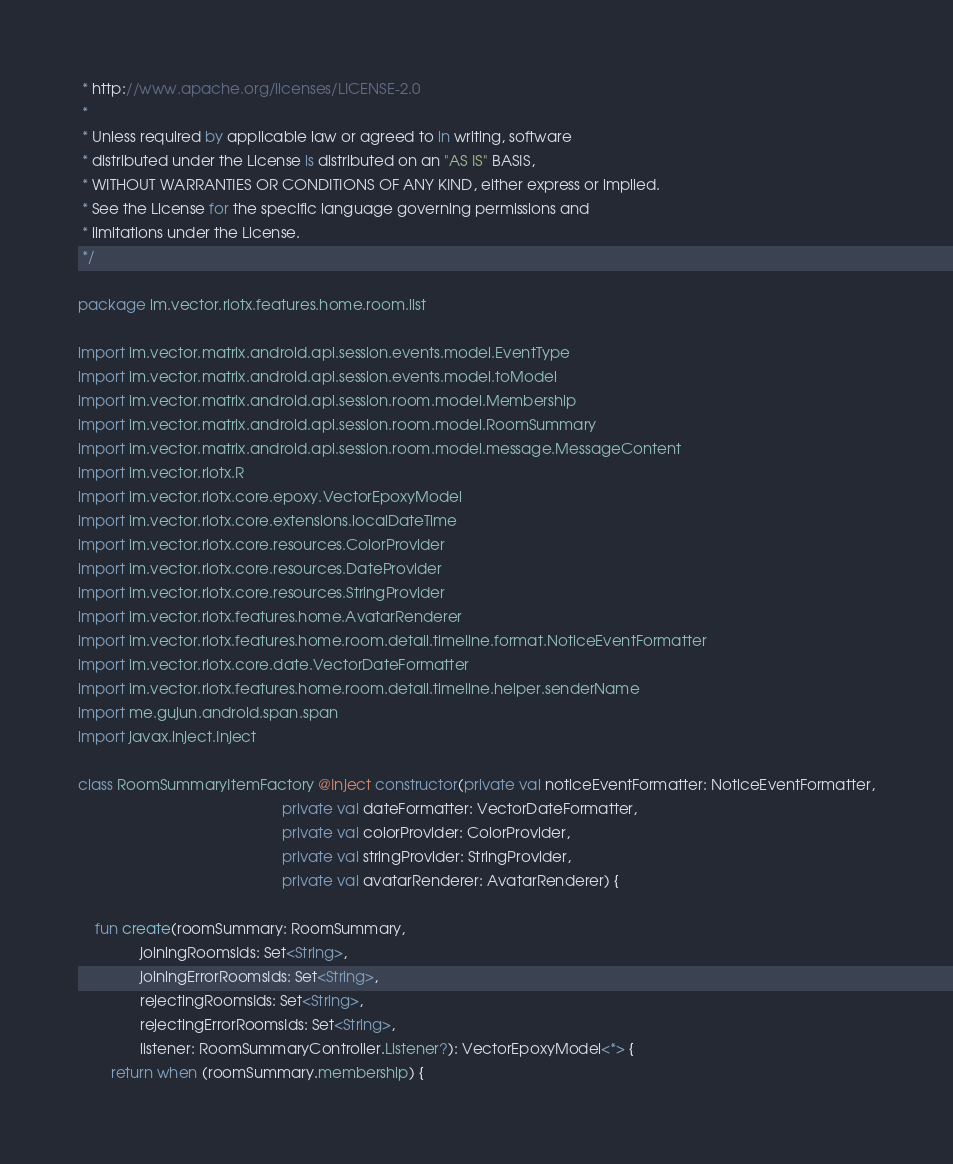Convert code to text. <code><loc_0><loc_0><loc_500><loc_500><_Kotlin_> * http://www.apache.org/licenses/LICENSE-2.0
 *
 * Unless required by applicable law or agreed to in writing, software
 * distributed under the License is distributed on an "AS IS" BASIS,
 * WITHOUT WARRANTIES OR CONDITIONS OF ANY KIND, either express or implied.
 * See the License for the specific language governing permissions and
 * limitations under the License.
 */

package im.vector.riotx.features.home.room.list

import im.vector.matrix.android.api.session.events.model.EventType
import im.vector.matrix.android.api.session.events.model.toModel
import im.vector.matrix.android.api.session.room.model.Membership
import im.vector.matrix.android.api.session.room.model.RoomSummary
import im.vector.matrix.android.api.session.room.model.message.MessageContent
import im.vector.riotx.R
import im.vector.riotx.core.epoxy.VectorEpoxyModel
import im.vector.riotx.core.extensions.localDateTime
import im.vector.riotx.core.resources.ColorProvider
import im.vector.riotx.core.resources.DateProvider
import im.vector.riotx.core.resources.StringProvider
import im.vector.riotx.features.home.AvatarRenderer
import im.vector.riotx.features.home.room.detail.timeline.format.NoticeEventFormatter
import im.vector.riotx.core.date.VectorDateFormatter
import im.vector.riotx.features.home.room.detail.timeline.helper.senderName
import me.gujun.android.span.span
import javax.inject.Inject

class RoomSummaryItemFactory @Inject constructor(private val noticeEventFormatter: NoticeEventFormatter,
                                                 private val dateFormatter: VectorDateFormatter,
                                                 private val colorProvider: ColorProvider,
                                                 private val stringProvider: StringProvider,
                                                 private val avatarRenderer: AvatarRenderer) {

    fun create(roomSummary: RoomSummary,
               joiningRoomsIds: Set<String>,
               joiningErrorRoomsIds: Set<String>,
               rejectingRoomsIds: Set<String>,
               rejectingErrorRoomsIds: Set<String>,
               listener: RoomSummaryController.Listener?): VectorEpoxyModel<*> {
        return when (roomSummary.membership) {</code> 